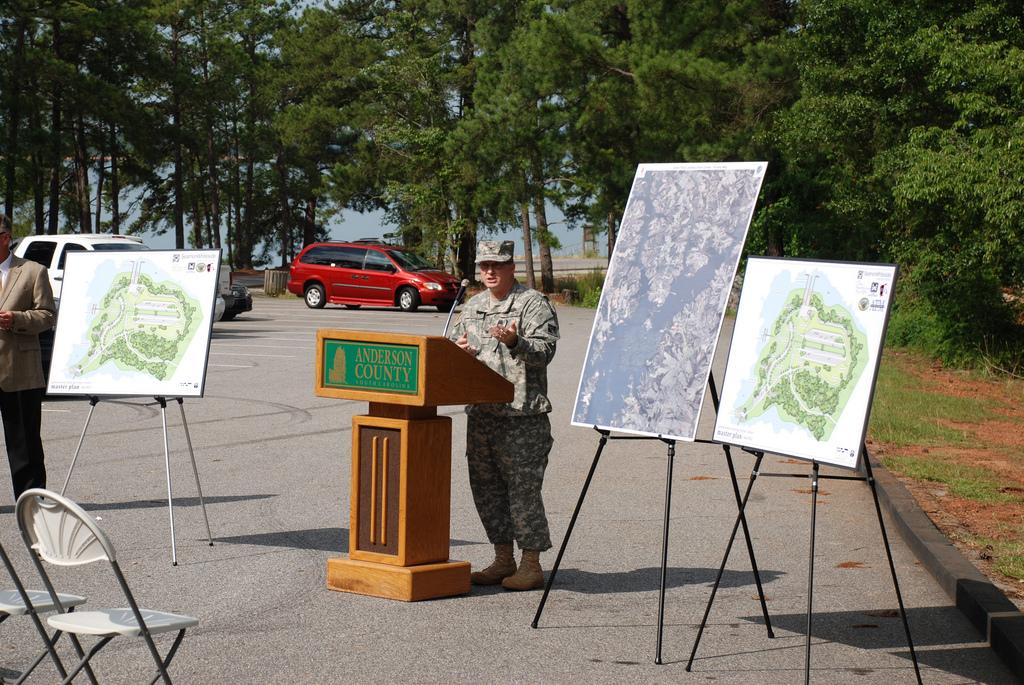What is the person in the image doing? The person is standing in the image. What is in front of the person? There is a podium with a mic in front of the person. What can be seen on the walls in the image? There are posters in the image. What type of furniture is present in the image? There are chairs in the image. What is visible in the background of the image? There are vehicles and trees in the image. What type of glove is the person wearing in the image? There is no glove visible on the person in the image. What type of gate is present in the image? There is no gate present in the image. 